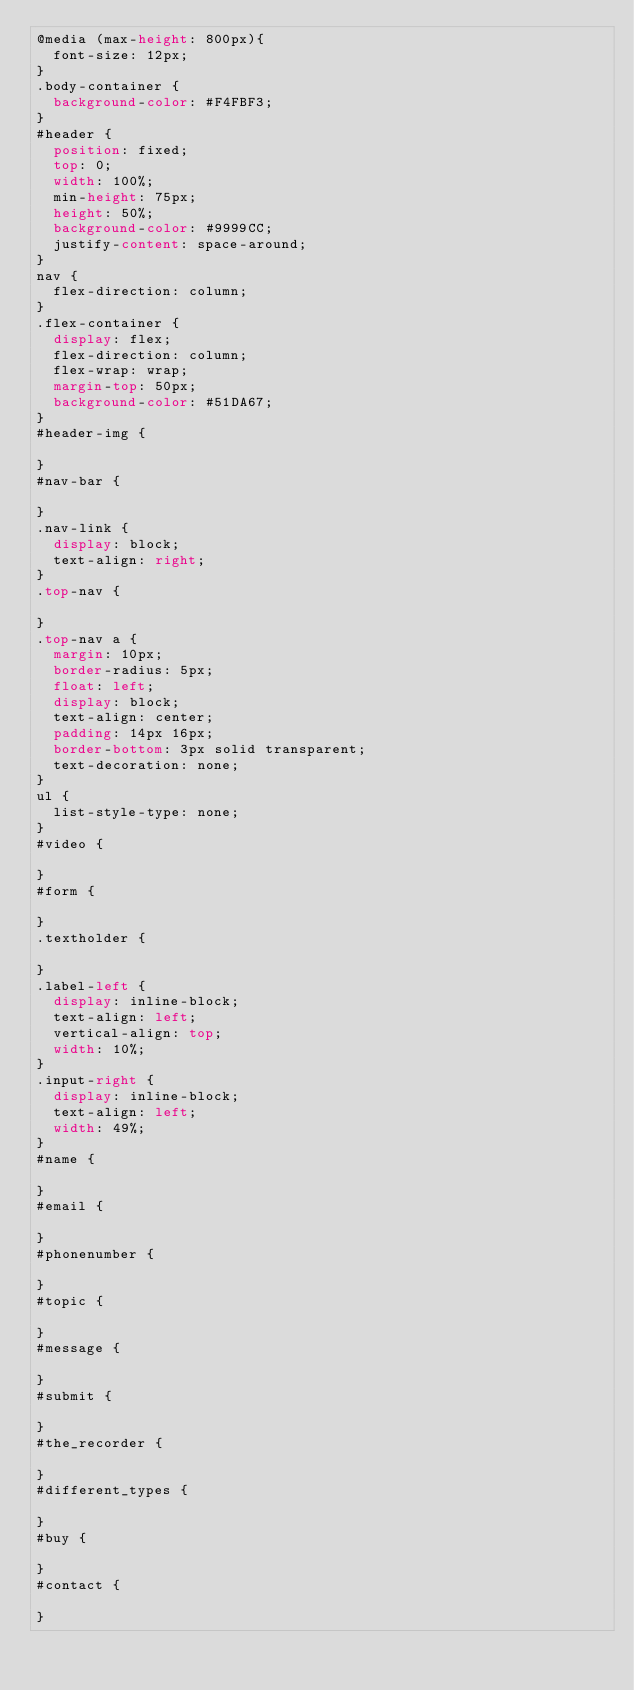Convert code to text. <code><loc_0><loc_0><loc_500><loc_500><_CSS_>@media (max-height: 800px){
  font-size: 12px;
}
.body-container {
  background-color: #F4FBF3;
}
#header {
  position: fixed;
  top: 0;
  width: 100%;
  min-height: 75px;
  height: 50%;
  background-color: #9999CC;
  justify-content: space-around;
}
nav {
  flex-direction: column;
}
.flex-container {
  display: flex;
  flex-direction: column;
  flex-wrap: wrap;
  margin-top: 50px;
  background-color: #51DA67;
}
#header-img {
  
}
#nav-bar {

}
.nav-link {
  display: block;
  text-align: right;
}
.top-nav {
  
}
.top-nav a {
  margin: 10px;
  border-radius: 5px;
  float: left;
  display: block;
  text-align: center;
  padding: 14px 16px;
  border-bottom: 3px solid transparent;
  text-decoration: none;
}
ul {
  list-style-type: none;
}
#video {
  
}
#form {
  
}
.textholder {
  
}
.label-left {
  display: inline-block;
  text-align: left;
  vertical-align: top;
  width: 10%;
}
.input-right {
  display: inline-block;
  text-align: left;
  width: 49%;
}
#name {
  
}
#email {
  
}
#phonenumber {
  
}
#topic {
  
}
#message {
  
}
#submit {
  
}
#the_recorder {
  
}
#different_types {
  
}
#buy {
  
}
#contact {
  
}</code> 